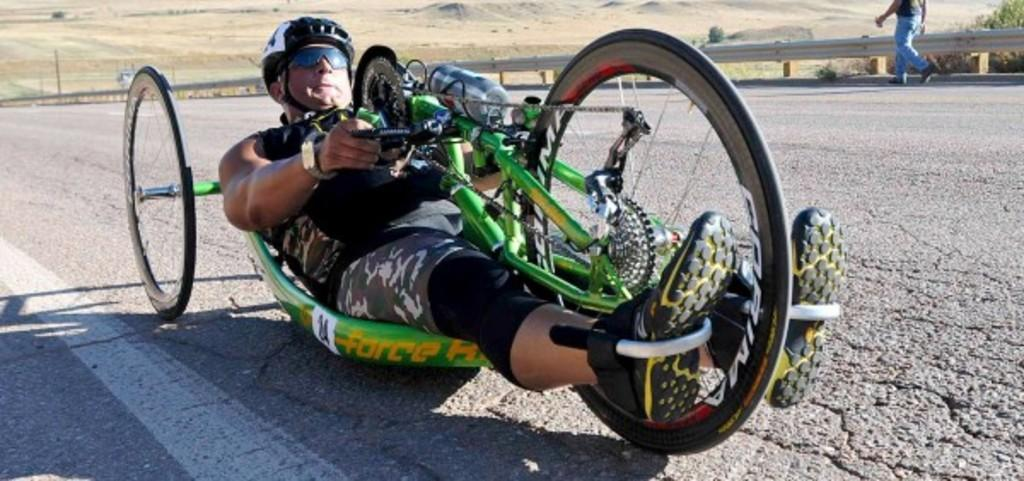What is the main subject of the image? There is a person on a vehicle in the image. What can be seen in the background of the image? There is an open land in the background of the image. Are there any other people visible in the image? Yes, there is a person walking on the road in the image. What type of pizzas is the person on the vehicle eating in the image? There is no pizza present in the image; the person on the vehicle is not eating anything. 